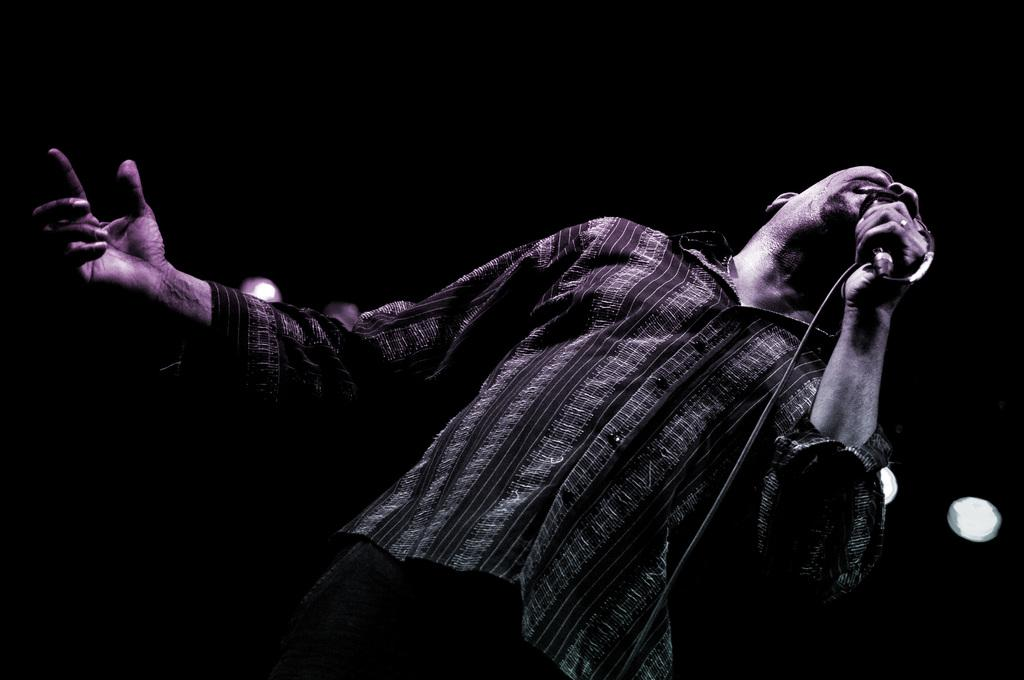Who is the main subject in the image? There is a man in the image. What is the man doing in the image? The man is standing and holding a mic. What can be seen in the background of the image? There are lights in the background of the image. What type of flower is the man holding in the image? The man is not holding a flower in the image; he is holding a mic. 